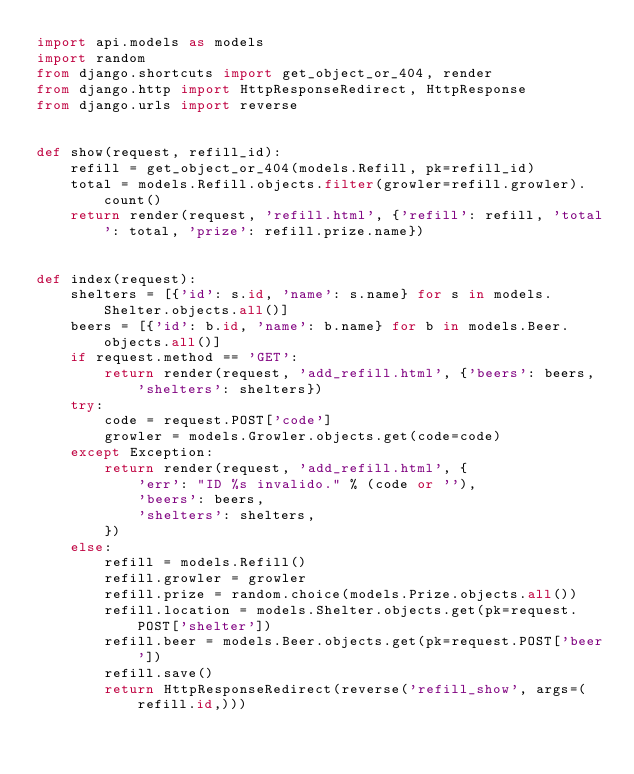Convert code to text. <code><loc_0><loc_0><loc_500><loc_500><_Python_>import api.models as models
import random
from django.shortcuts import get_object_or_404, render
from django.http import HttpResponseRedirect, HttpResponse
from django.urls import reverse


def show(request, refill_id):
    refill = get_object_or_404(models.Refill, pk=refill_id)
    total = models.Refill.objects.filter(growler=refill.growler).count()
    return render(request, 'refill.html', {'refill': refill, 'total': total, 'prize': refill.prize.name})


def index(request):
    shelters = [{'id': s.id, 'name': s.name} for s in models.Shelter.objects.all()]
    beers = [{'id': b.id, 'name': b.name} for b in models.Beer.objects.all()]
    if request.method == 'GET':
        return render(request, 'add_refill.html', {'beers': beers, 'shelters': shelters})
    try:
        code = request.POST['code']
        growler = models.Growler.objects.get(code=code)
    except Exception:
        return render(request, 'add_refill.html', {
            'err': "ID %s invalido." % (code or ''),
            'beers': beers,
            'shelters': shelters,
        })
    else:
        refill = models.Refill()
        refill.growler = growler
        refill.prize = random.choice(models.Prize.objects.all())
        refill.location = models.Shelter.objects.get(pk=request.POST['shelter'])
        refill.beer = models.Beer.objects.get(pk=request.POST['beer'])
        refill.save()
        return HttpResponseRedirect(reverse('refill_show', args=(refill.id,)))
</code> 